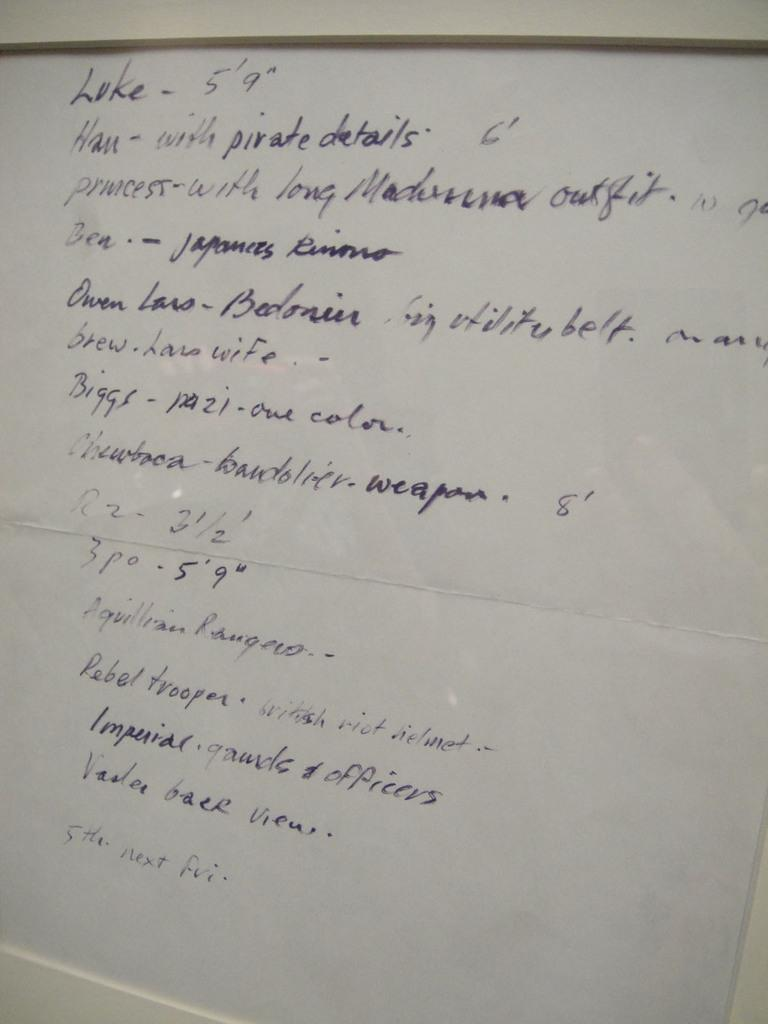What is the main object in the image? There is a board in the image. What is written or displayed on the board? There is text on the board. How does the authority of the spoon affect the text on the board? There is no spoon present in the image, and therefore its authority cannot affect the text on the board. 